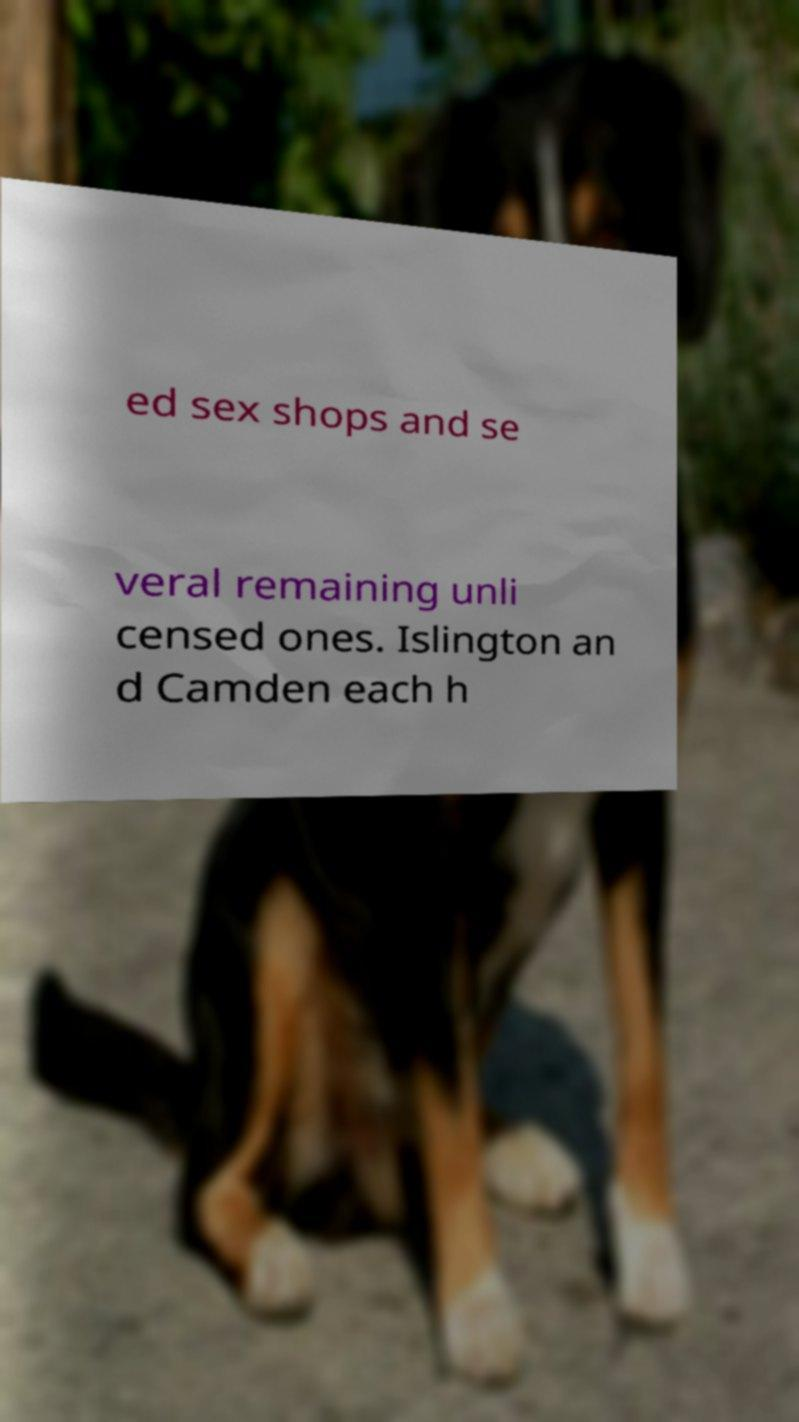For documentation purposes, I need the text within this image transcribed. Could you provide that? ed sex shops and se veral remaining unli censed ones. Islington an d Camden each h 